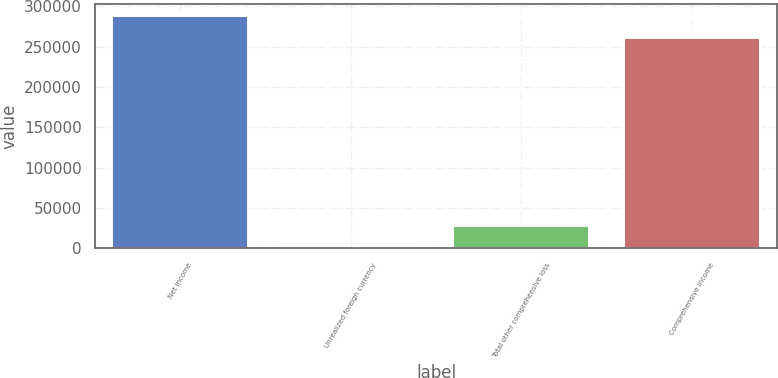Convert chart to OTSL. <chart><loc_0><loc_0><loc_500><loc_500><bar_chart><fcel>Net income<fcel>Unrealized foreign currency<fcel>Total other comprehensive loss<fcel>Comprehensive income<nl><fcel>288532<fcel>183<fcel>28440.5<fcel>260274<nl></chart> 